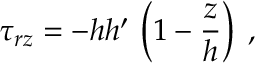Convert formula to latex. <formula><loc_0><loc_0><loc_500><loc_500>\tau _ { r z } = - h h ^ { \prime } \, \left ( 1 - \frac { z } { h } \right ) \, ,</formula> 